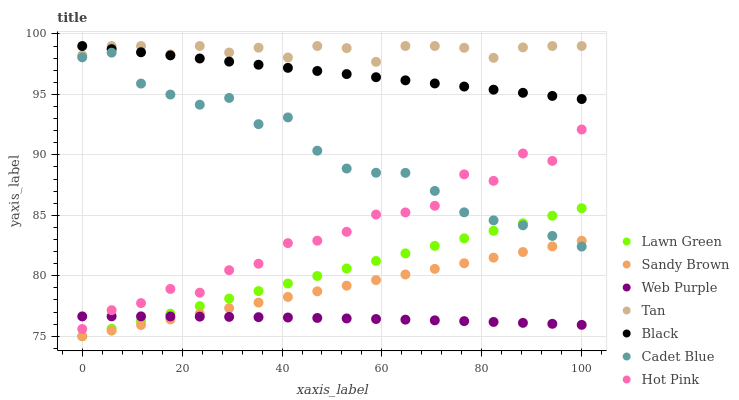Does Web Purple have the minimum area under the curve?
Answer yes or no. Yes. Does Tan have the maximum area under the curve?
Answer yes or no. Yes. Does Cadet Blue have the minimum area under the curve?
Answer yes or no. No. Does Cadet Blue have the maximum area under the curve?
Answer yes or no. No. Is Lawn Green the smoothest?
Answer yes or no. Yes. Is Hot Pink the roughest?
Answer yes or no. Yes. Is Cadet Blue the smoothest?
Answer yes or no. No. Is Cadet Blue the roughest?
Answer yes or no. No. Does Lawn Green have the lowest value?
Answer yes or no. Yes. Does Cadet Blue have the lowest value?
Answer yes or no. No. Does Tan have the highest value?
Answer yes or no. Yes. Does Cadet Blue have the highest value?
Answer yes or no. No. Is Hot Pink less than Black?
Answer yes or no. Yes. Is Tan greater than Web Purple?
Answer yes or no. Yes. Does Cadet Blue intersect Hot Pink?
Answer yes or no. Yes. Is Cadet Blue less than Hot Pink?
Answer yes or no. No. Is Cadet Blue greater than Hot Pink?
Answer yes or no. No. Does Hot Pink intersect Black?
Answer yes or no. No. 